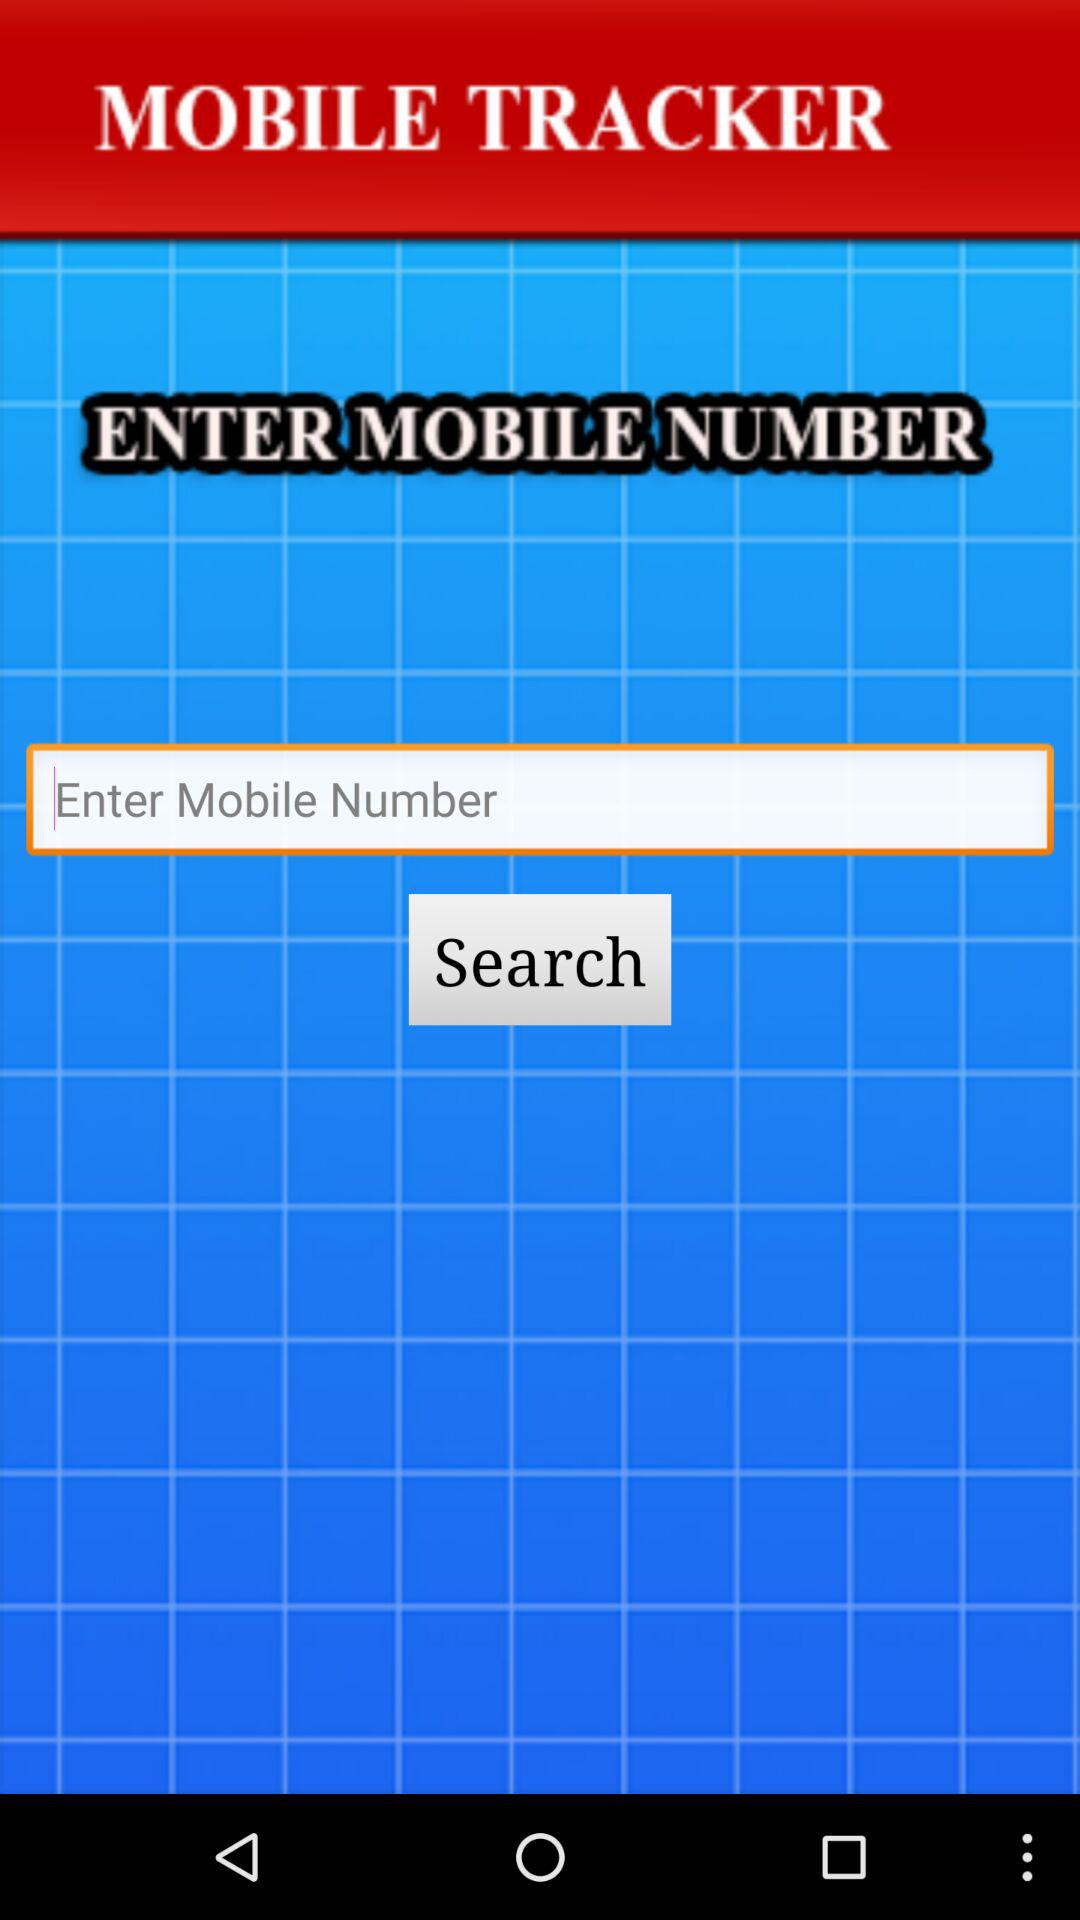What is the app name? The app name is "MOBILE TRACKER". 